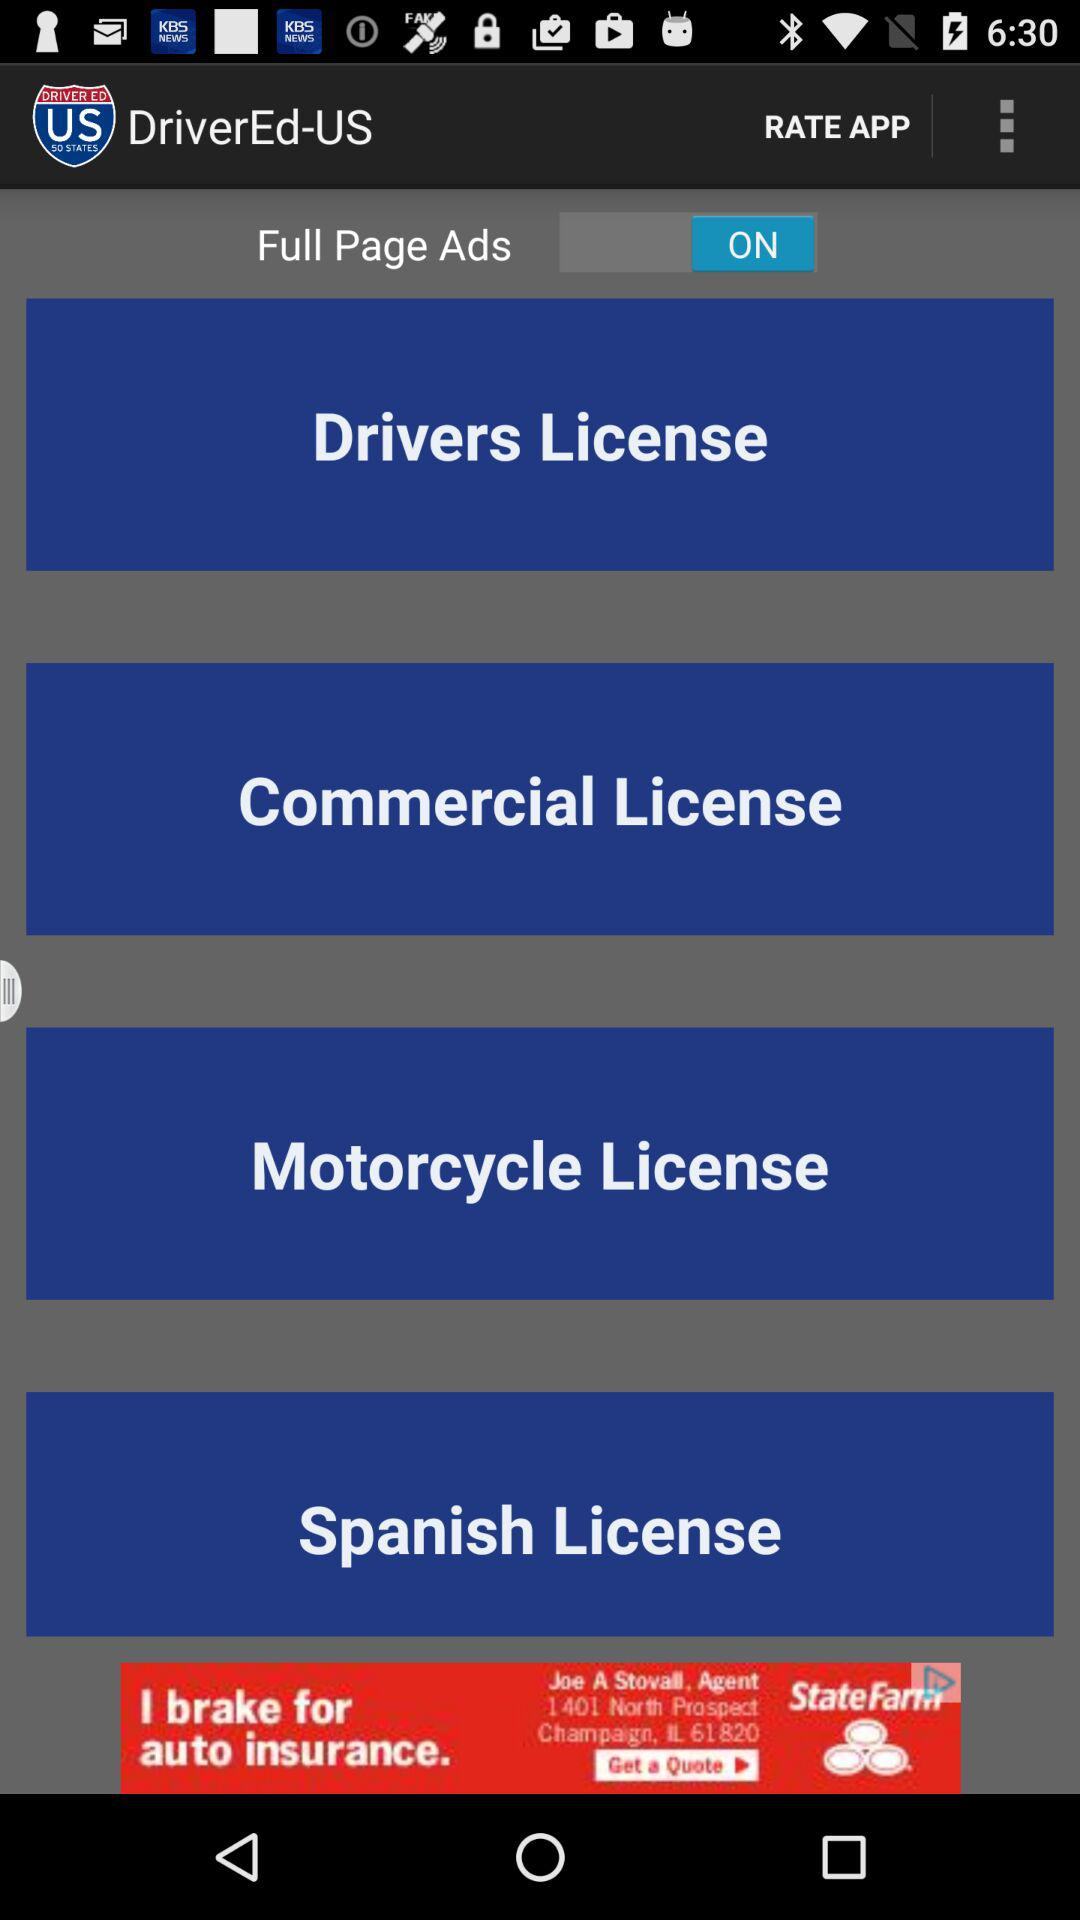What is the status of full page ads? The status is on. 